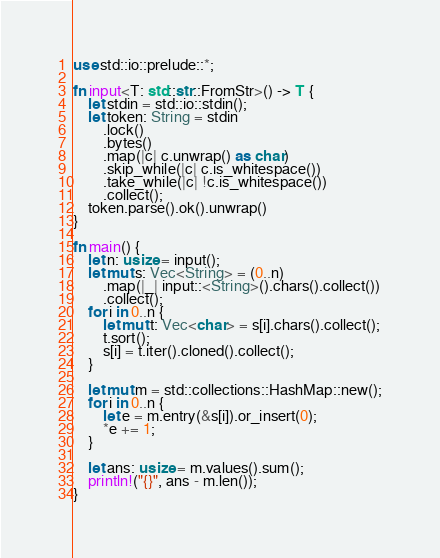<code> <loc_0><loc_0><loc_500><loc_500><_Rust_>use std::io::prelude::*;

fn input<T: std::str::FromStr>() -> T {
    let stdin = std::io::stdin();
    let token: String = stdin
        .lock()
        .bytes()
        .map(|c| c.unwrap() as char)
        .skip_while(|c| c.is_whitespace())
        .take_while(|c| !c.is_whitespace())
        .collect();
    token.parse().ok().unwrap()
}

fn main() {
    let n: usize = input();
    let mut s: Vec<String> = (0..n)
        .map(|_| input::<String>().chars().collect())
        .collect();
    for i in 0..n {
        let mut t: Vec<char> = s[i].chars().collect();
        t.sort();
        s[i] = t.iter().cloned().collect();
    }

    let mut m = std::collections::HashMap::new();
    for i in 0..n {
        let e = m.entry(&s[i]).or_insert(0);
        *e += 1;
    }

    let ans: usize = m.values().sum();
    println!("{}", ans - m.len());
}
</code> 